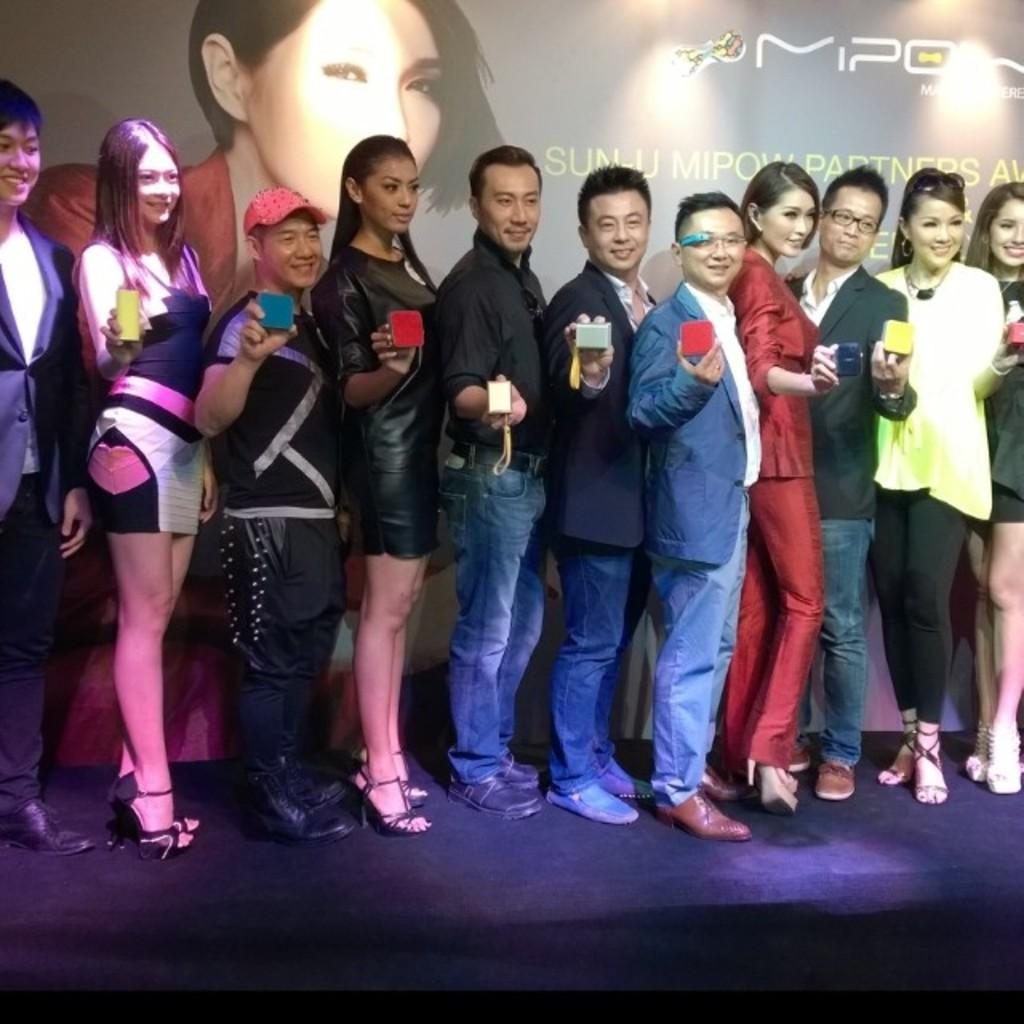What are the people in the image doing? The people in the image are standing and holding objects. What can be seen in the background of the image? There is a poster in the background of the image. What is depicted on the poster? The poster contains an image. What else is featured on the poster besides the image? The poster contains text. What type of question is being asked by the person on the left side of the image? There is no person asking a question in the image; the people are holding objects. What is the process being depicted on the poster in the image? The poster does not depict a process; it contains an image and text. 